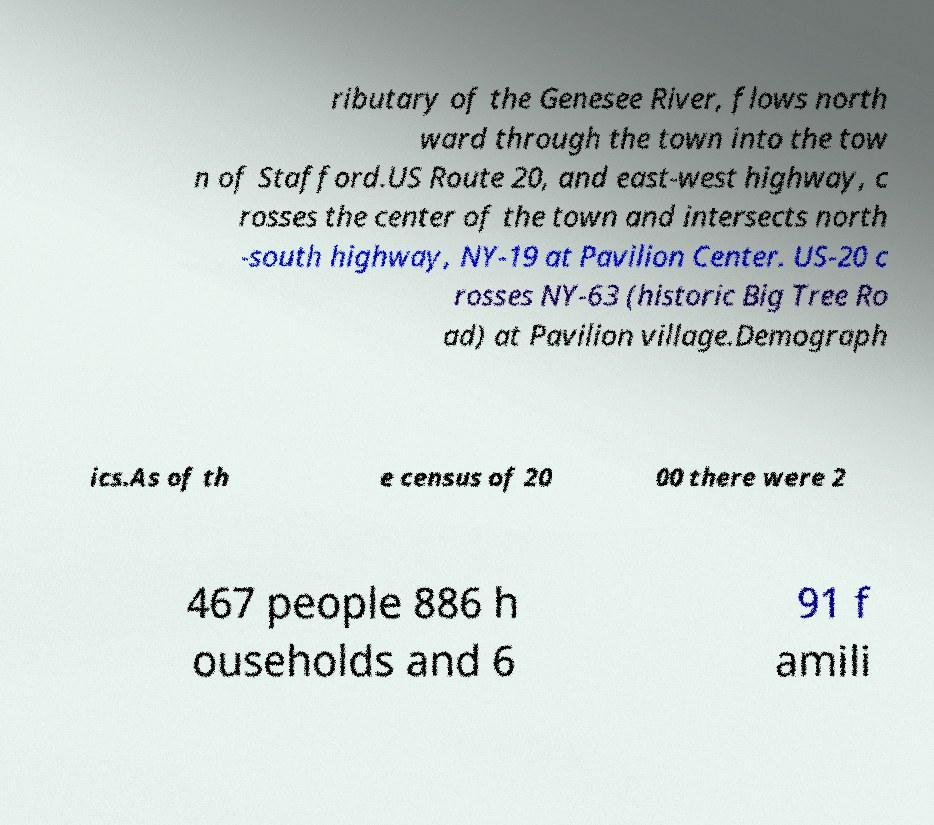Please identify and transcribe the text found in this image. ributary of the Genesee River, flows north ward through the town into the tow n of Stafford.US Route 20, and east-west highway, c rosses the center of the town and intersects north -south highway, NY-19 at Pavilion Center. US-20 c rosses NY-63 (historic Big Tree Ro ad) at Pavilion village.Demograph ics.As of th e census of 20 00 there were 2 467 people 886 h ouseholds and 6 91 f amili 